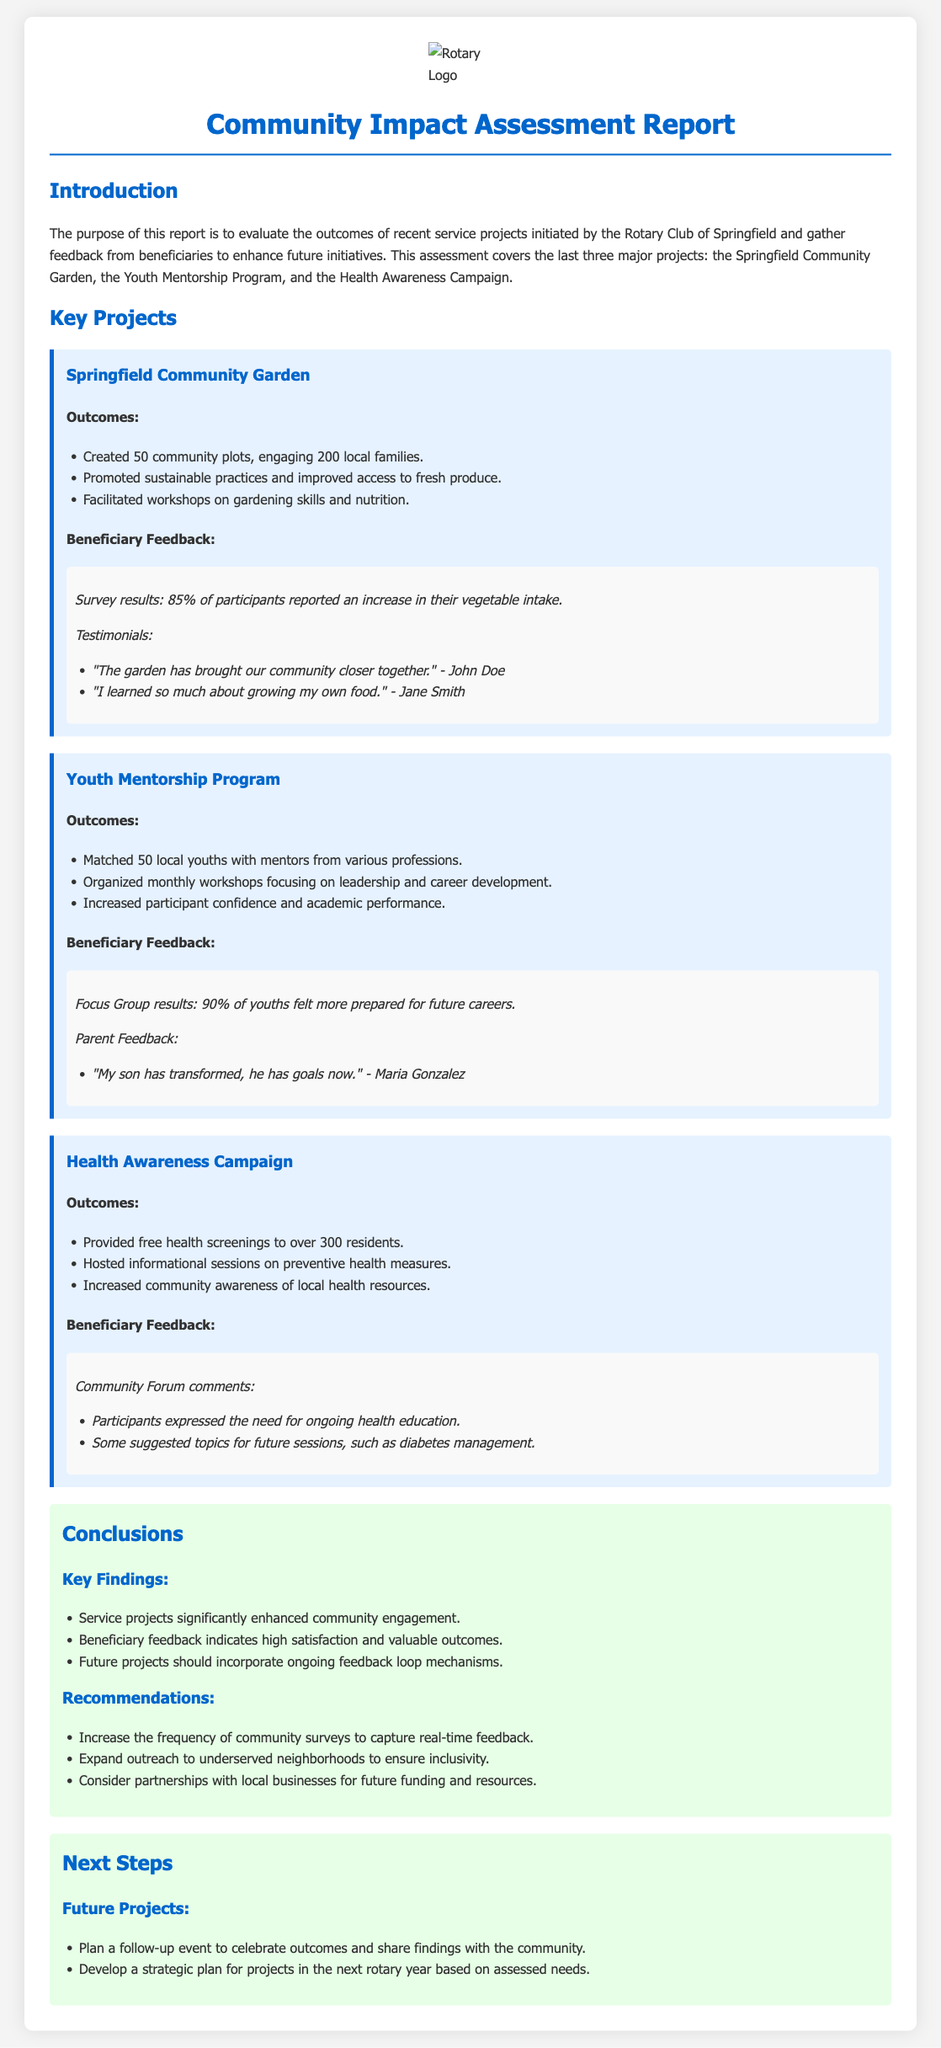What is the title of the report? The title of the report is found at the top of the document.
Answer: Community Impact Assessment Report How many community plots were created in the Springfield Community Garden? This information is listed under the outcomes of the Springfield Community Garden.
Answer: 50 community plots What percentage of participants reported an increase in vegetable intake? This statistic is included in the beneficiary feedback of the Springfield Community Garden project.
Answer: 85% How many local youths were matched with mentors in the Youth Mentorship Program? This figure is mentioned under the outcomes of the Youth Mentorship Program.
Answer: 50 local youths What was a key recommendation made in the conclusions? Key recommendations are listed in the conclusions section, focusing on future improvements.
Answer: Increase the frequency of community surveys What was the main outcome of the Health Awareness Campaign? The outcomes are summarized in the document, highlighting the primary achievements of the campaign.
Answer: Provided free health screenings to over 300 residents Which project received feedback indicating participants wanted ongoing health education? The feedback is gathered from the beneficiaries of each project, specifically for the Health Awareness Campaign.
Answer: Health Awareness Campaign What was a future project mentioned in the next steps section? The next steps include future projects that the community can anticipate.
Answer: Plan a follow-up event to celebrate outcomes 